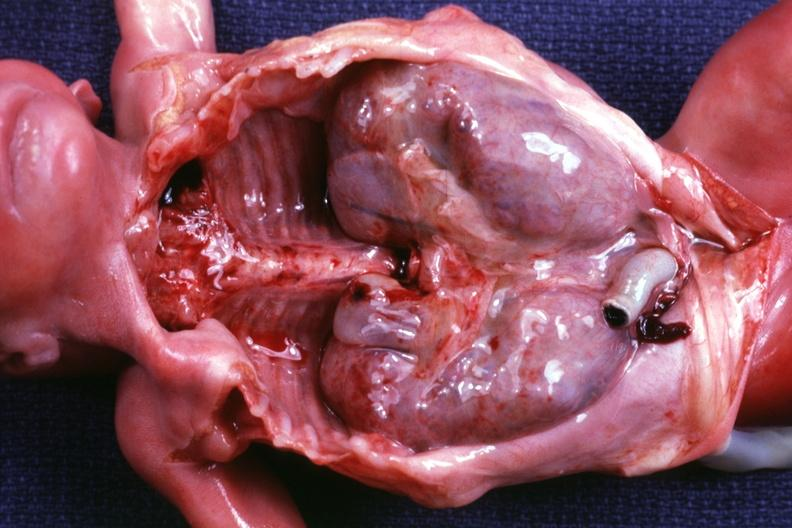s this therapy present?
Answer the question using a single word or phrase. No 